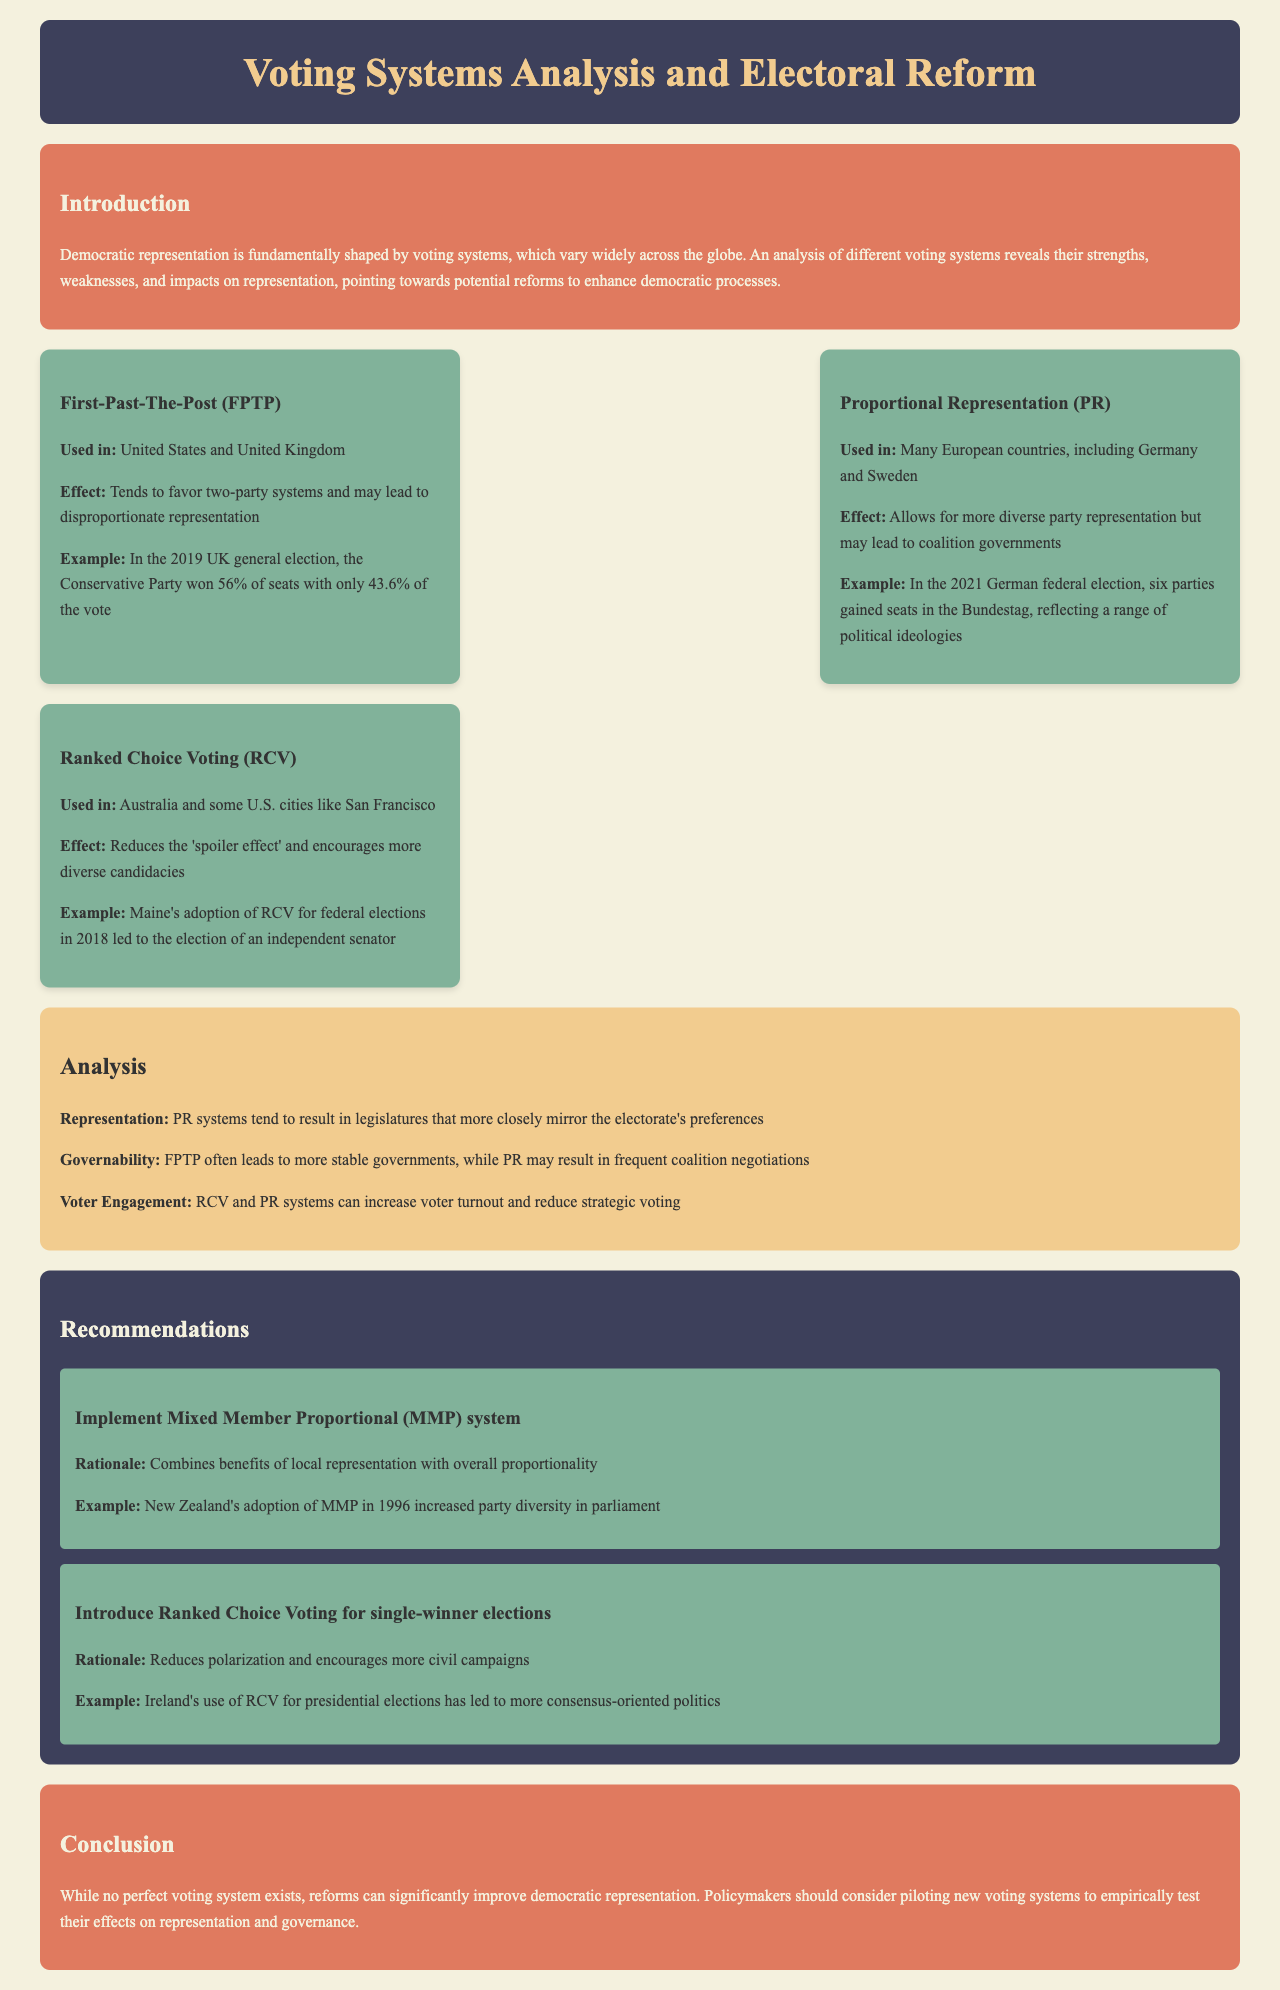What is the title of the document? The title of the document is stated in the header section.
Answer: Voting Systems Analysis and Electoral Reform Which voting system is used in the United States? The document lists voting systems and their usage in various countries.
Answer: First-Past-The-Post (FPTP) What effect does Proportional Representation (PR) have? The document describes the effects of different voting systems, including PR.
Answer: Allows for more diverse party representation What example is given for Ranked Choice Voting (RCV)? An example illustrating the use of RCV is included in the section about RCV.
Answer: Maine's adoption of RCV for federal elections in 2018 What is one recommendation made for electoral reform? Recommendations are provided for improving electoral systems.
Answer: Implement Mixed Member Proportional (MMP) system How does FPTP affect party systems? The document discusses the implications of each voting system on party dynamics.
Answer: Tends to favor two-party systems What is a benefit of using RCV? The analysis section highlights advantages of different systems, including RCV.
Answer: Reduces the 'spoiler effect' What year did New Zealand adopt the MMP system? The recommendation section provides an example of MMP adoption along with its year.
Answer: 1996 